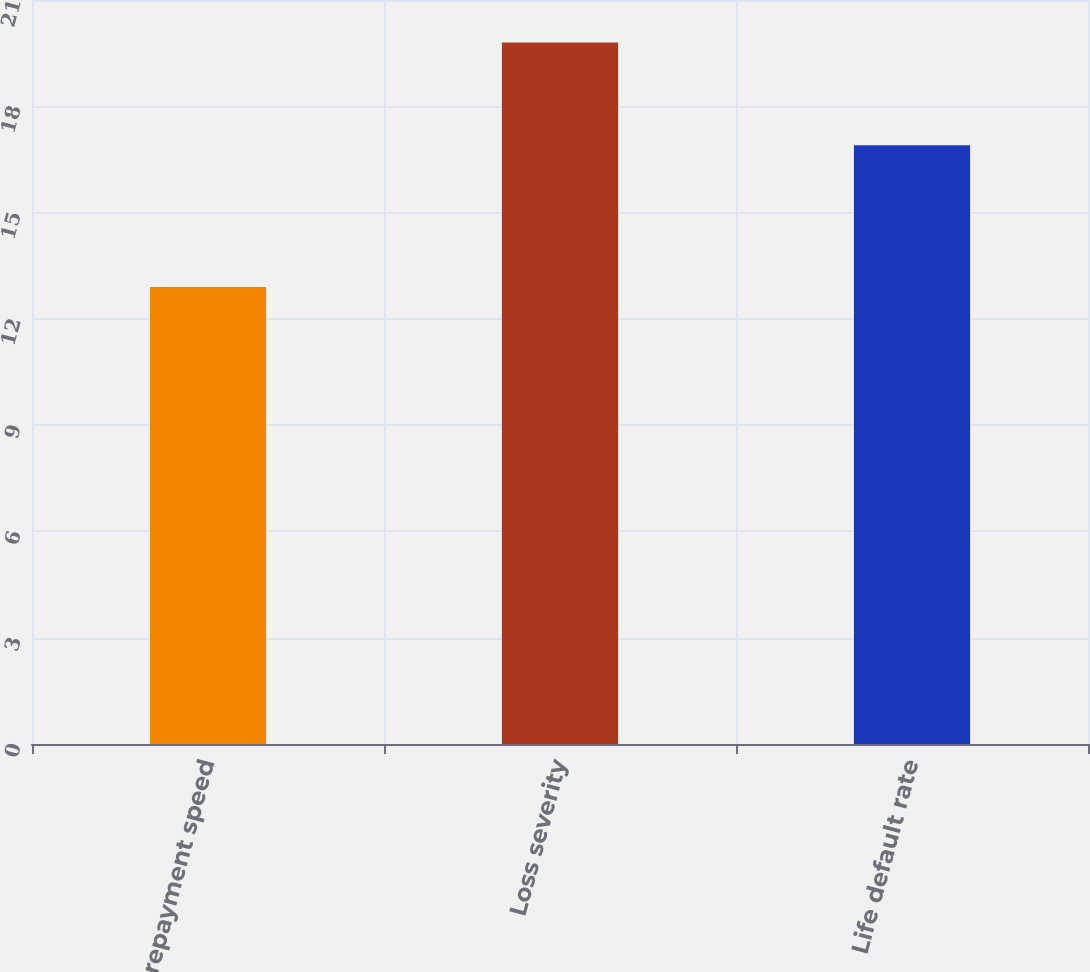Convert chart. <chart><loc_0><loc_0><loc_500><loc_500><bar_chart><fcel>Prepayment speed<fcel>Loss severity<fcel>Life default rate<nl><fcel>12.9<fcel>19.8<fcel>16.9<nl></chart> 